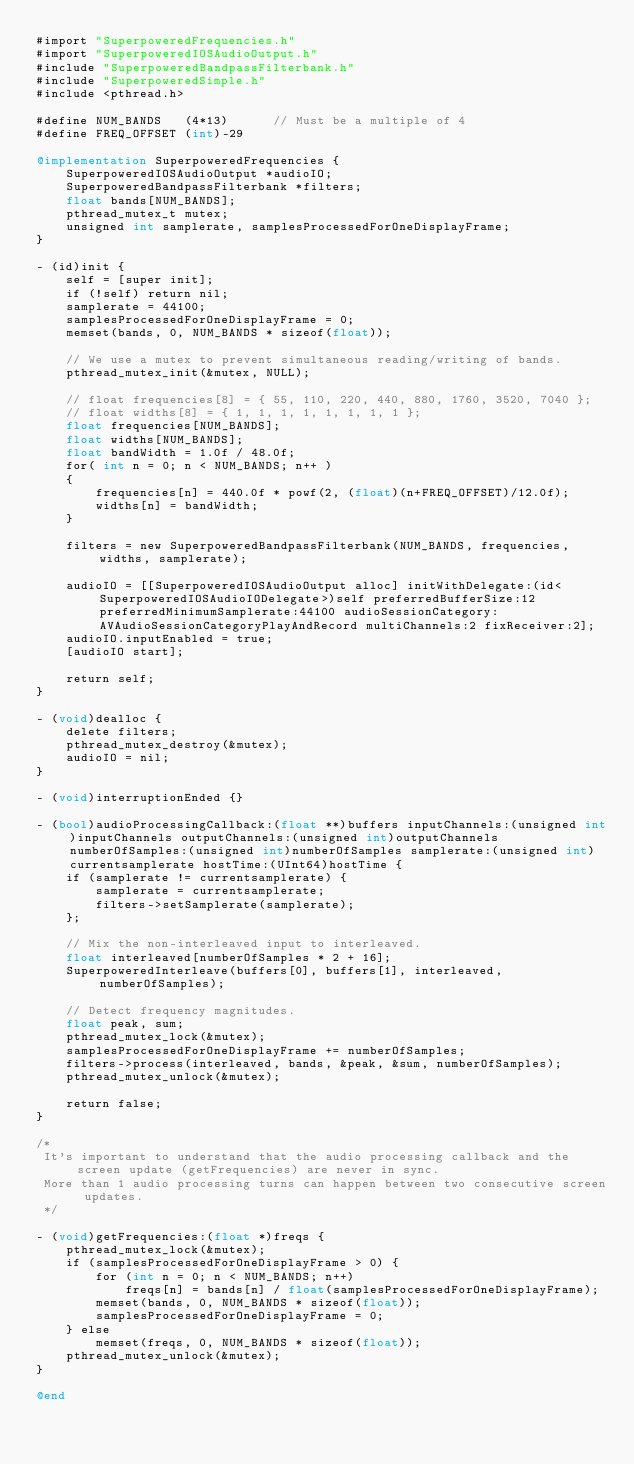Convert code to text. <code><loc_0><loc_0><loc_500><loc_500><_ObjectiveC_>#import "SuperpoweredFrequencies.h"
#import "SuperpoweredIOSAudioOutput.h"
#include "SuperpoweredBandpassFilterbank.h"
#include "SuperpoweredSimple.h"
#include <pthread.h>

#define NUM_BANDS   (4*13)      // Must be a multiple of 4
#define FREQ_OFFSET (int)-29

@implementation SuperpoweredFrequencies {
    SuperpoweredIOSAudioOutput *audioIO;
    SuperpoweredBandpassFilterbank *filters;
    float bands[NUM_BANDS];
    pthread_mutex_t mutex;
    unsigned int samplerate, samplesProcessedForOneDisplayFrame;
}

- (id)init {
    self = [super init];
    if (!self) return nil;
    samplerate = 44100;
    samplesProcessedForOneDisplayFrame = 0;
    memset(bands, 0, NUM_BANDS * sizeof(float));
    
    // We use a mutex to prevent simultaneous reading/writing of bands.
    pthread_mutex_init(&mutex, NULL);
    
    // float frequencies[8] = { 55, 110, 220, 440, 880, 1760, 3520, 7040 };
    // float widths[8] = { 1, 1, 1, 1, 1, 1, 1, 1 };
    float frequencies[NUM_BANDS];
    float widths[NUM_BANDS];
    float bandWidth = 1.0f / 48.0f;
    for( int n = 0; n < NUM_BANDS; n++ )
    {
        frequencies[n] = 440.0f * powf(2, (float)(n+FREQ_OFFSET)/12.0f);
        widths[n] = bandWidth;
    }
    
    filters = new SuperpoweredBandpassFilterbank(NUM_BANDS, frequencies, widths, samplerate);
    
    audioIO = [[SuperpoweredIOSAudioOutput alloc] initWithDelegate:(id<SuperpoweredIOSAudioIODelegate>)self preferredBufferSize:12 preferredMinimumSamplerate:44100 audioSessionCategory:AVAudioSessionCategoryPlayAndRecord multiChannels:2 fixReceiver:2];
    audioIO.inputEnabled = true;
    [audioIO start];
    
    return self;
}

- (void)dealloc {
    delete filters;
    pthread_mutex_destroy(&mutex);
    audioIO = nil;
}

- (void)interruptionEnded {}

- (bool)audioProcessingCallback:(float **)buffers inputChannels:(unsigned int)inputChannels outputChannels:(unsigned int)outputChannels numberOfSamples:(unsigned int)numberOfSamples samplerate:(unsigned int)currentsamplerate hostTime:(UInt64)hostTime {
    if (samplerate != currentsamplerate) {
        samplerate = currentsamplerate;
        filters->setSamplerate(samplerate);
    };
    
    // Mix the non-interleaved input to interleaved.
    float interleaved[numberOfSamples * 2 + 16];
    SuperpoweredInterleave(buffers[0], buffers[1], interleaved, numberOfSamples);
    
    // Detect frequency magnitudes.
    float peak, sum;
    pthread_mutex_lock(&mutex);
    samplesProcessedForOneDisplayFrame += numberOfSamples;
    filters->process(interleaved, bands, &peak, &sum, numberOfSamples);
    pthread_mutex_unlock(&mutex);
    
    return false;
}

/*
 It's important to understand that the audio processing callback and the screen update (getFrequencies) are never in sync. 
 More than 1 audio processing turns can happen between two consecutive screen updates.
 */

- (void)getFrequencies:(float *)freqs {
    pthread_mutex_lock(&mutex);
    if (samplesProcessedForOneDisplayFrame > 0) {
        for (int n = 0; n < NUM_BANDS; n++)
            freqs[n] = bands[n] / float(samplesProcessedForOneDisplayFrame);
        memset(bands, 0, NUM_BANDS * sizeof(float));
        samplesProcessedForOneDisplayFrame = 0;
    } else
        memset(freqs, 0, NUM_BANDS * sizeof(float));
    pthread_mutex_unlock(&mutex);
}

@end
</code> 